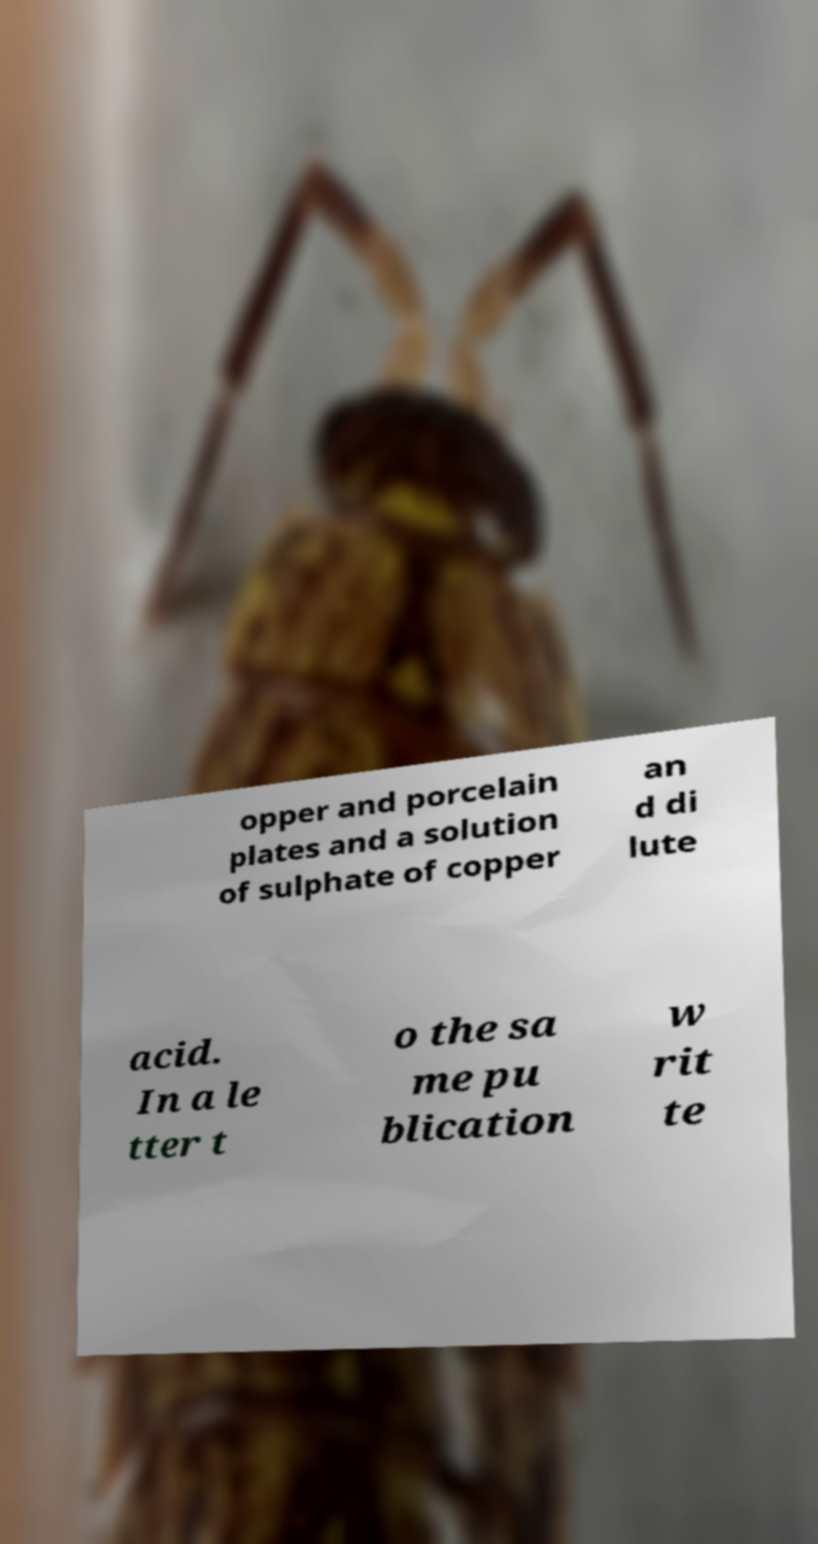Please identify and transcribe the text found in this image. opper and porcelain plates and a solution of sulphate of copper an d di lute acid. In a le tter t o the sa me pu blication w rit te 